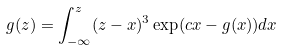Convert formula to latex. <formula><loc_0><loc_0><loc_500><loc_500>g ( z ) = \int _ { - \infty } ^ { z } ( z - x ) ^ { 3 } \exp ( c x - g ( x ) ) d x</formula> 